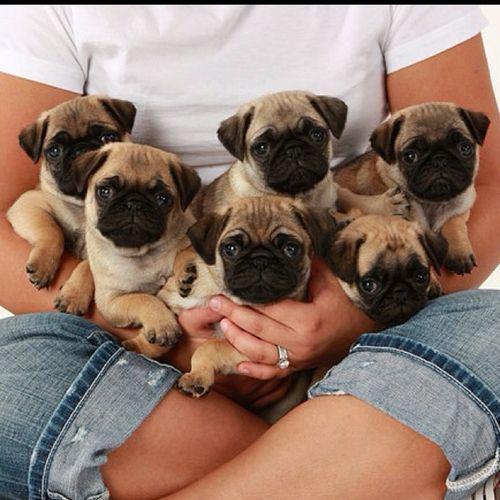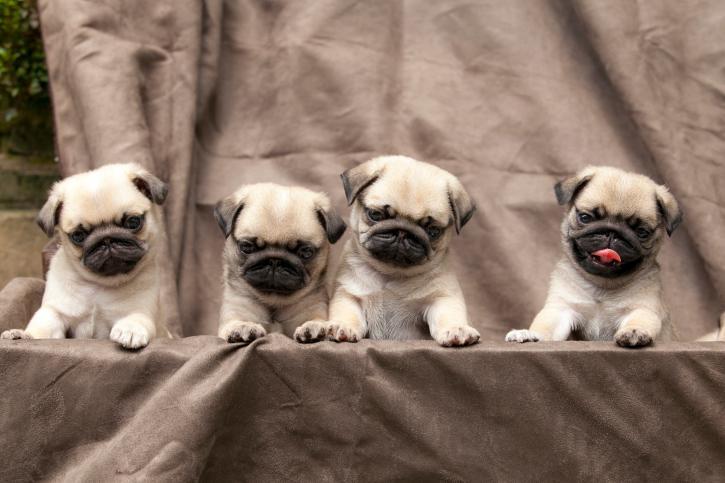The first image is the image on the left, the second image is the image on the right. Analyze the images presented: Is the assertion "There are exactly three dogs in the image on the right." valid? Answer yes or no. No. The first image is the image on the left, the second image is the image on the right. Evaluate the accuracy of this statement regarding the images: "At least one image includes black pugs.". Is it true? Answer yes or no. No. The first image is the image on the left, the second image is the image on the right. For the images displayed, is the sentence "There are no more than four puppies in the image on the right." factually correct? Answer yes or no. Yes. 